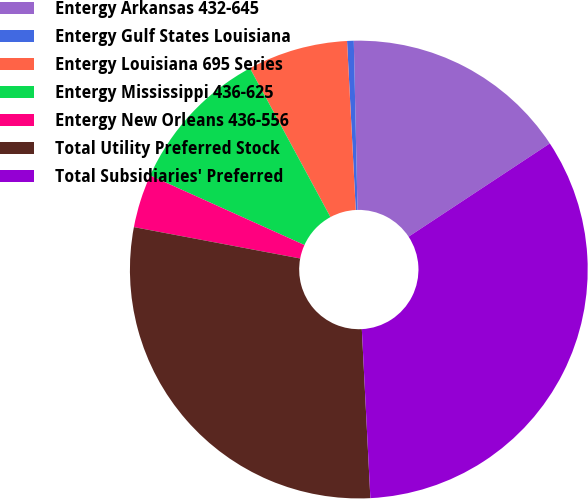Convert chart to OTSL. <chart><loc_0><loc_0><loc_500><loc_500><pie_chart><fcel>Entergy Arkansas 432-645<fcel>Entergy Gulf States Louisiana<fcel>Entergy Louisiana 695 Series<fcel>Entergy Mississippi 436-625<fcel>Entergy New Orleans 436-556<fcel>Total Utility Preferred Stock<fcel>Total Subsidiaries' Preferred<nl><fcel>16.06%<fcel>0.47%<fcel>7.07%<fcel>10.37%<fcel>3.77%<fcel>28.77%<fcel>33.48%<nl></chart> 